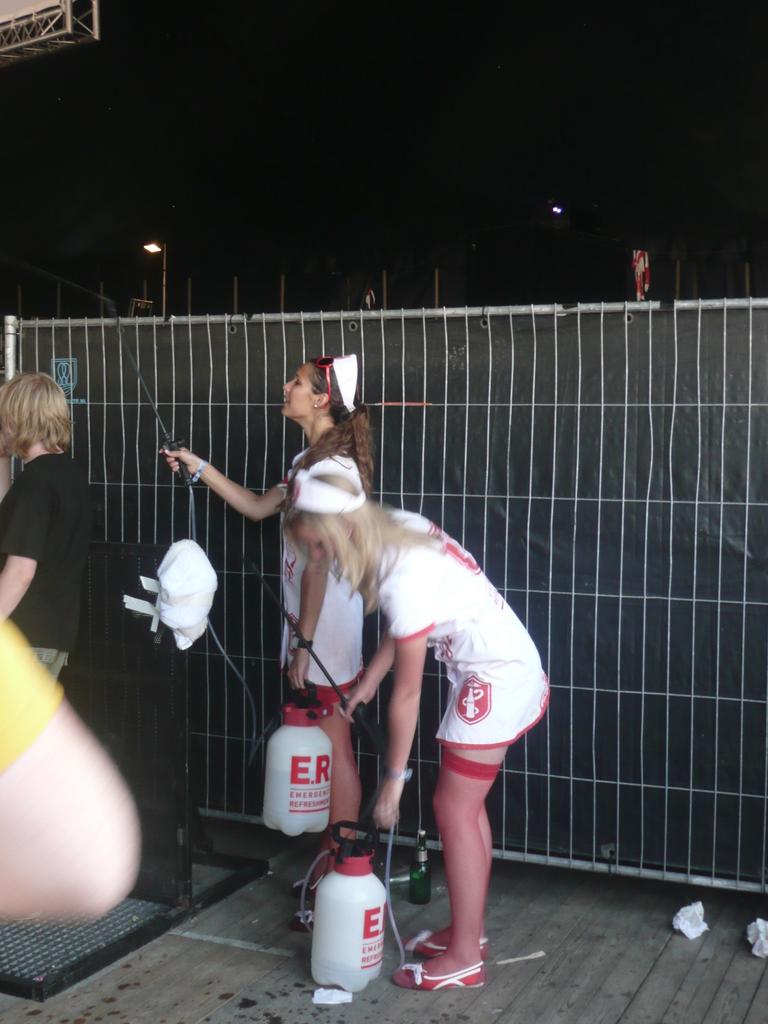What is in the bottles?
Your answer should be very brief. Emergency refreshment. What two letters in red are on the bottles?
Make the answer very short. Er. 